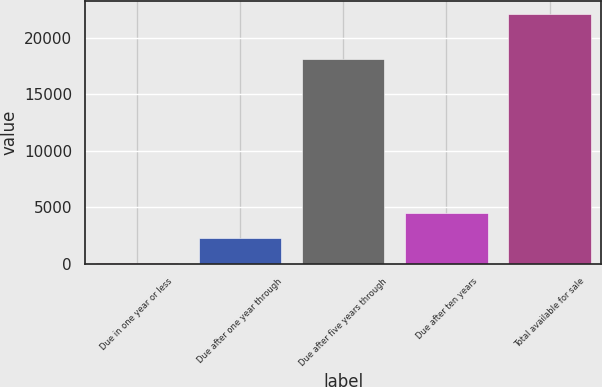Convert chart to OTSL. <chart><loc_0><loc_0><loc_500><loc_500><bar_chart><fcel>Due in one year or less<fcel>Due after one year through<fcel>Due after five years through<fcel>Due after ten years<fcel>Total available for sale<nl><fcel>68<fcel>2276.6<fcel>18092<fcel>4485.2<fcel>22154<nl></chart> 